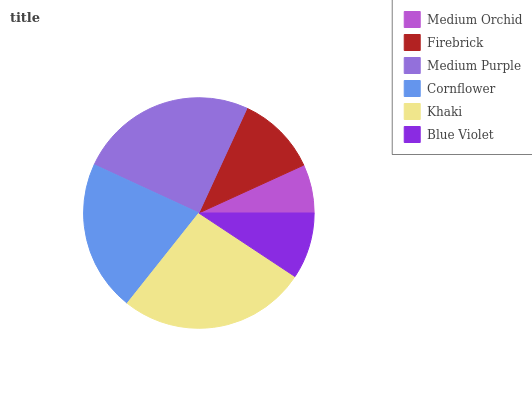Is Medium Orchid the minimum?
Answer yes or no. Yes. Is Khaki the maximum?
Answer yes or no. Yes. Is Firebrick the minimum?
Answer yes or no. No. Is Firebrick the maximum?
Answer yes or no. No. Is Firebrick greater than Medium Orchid?
Answer yes or no. Yes. Is Medium Orchid less than Firebrick?
Answer yes or no. Yes. Is Medium Orchid greater than Firebrick?
Answer yes or no. No. Is Firebrick less than Medium Orchid?
Answer yes or no. No. Is Cornflower the high median?
Answer yes or no. Yes. Is Firebrick the low median?
Answer yes or no. Yes. Is Firebrick the high median?
Answer yes or no. No. Is Medium Purple the low median?
Answer yes or no. No. 